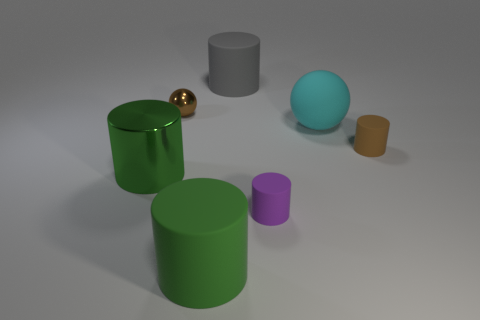Subtract all green blocks. How many green cylinders are left? 2 Add 2 cyan cylinders. How many objects exist? 9 Subtract all brown cylinders. How many cylinders are left? 4 Subtract all green cylinders. How many cylinders are left? 3 Subtract all balls. How many objects are left? 5 Subtract all red cylinders. Subtract all brown blocks. How many cylinders are left? 5 Add 2 tiny blue rubber things. How many tiny blue rubber things exist? 2 Subtract 1 gray cylinders. How many objects are left? 6 Subtract all big green cylinders. Subtract all brown cylinders. How many objects are left? 4 Add 1 cyan rubber things. How many cyan rubber things are left? 2 